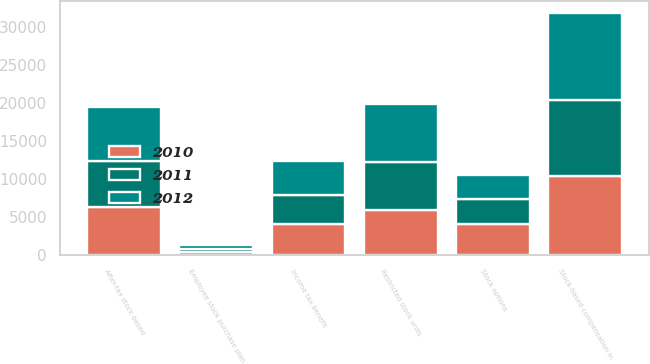<chart> <loc_0><loc_0><loc_500><loc_500><stacked_bar_chart><ecel><fcel>Stock options<fcel>Restricted stock units<fcel>Employee stock purchase plan<fcel>Stock-based compensation in<fcel>Income tax benefit<fcel>After-tax stock-based<nl><fcel>2012<fcel>3282<fcel>7658<fcel>530<fcel>11470<fcel>4473<fcel>6997<nl><fcel>2011<fcel>3182<fcel>6340<fcel>486<fcel>10008<fcel>3903<fcel>6105<nl><fcel>2010<fcel>4116<fcel>5863<fcel>355<fcel>10334<fcel>4030<fcel>6304<nl></chart> 